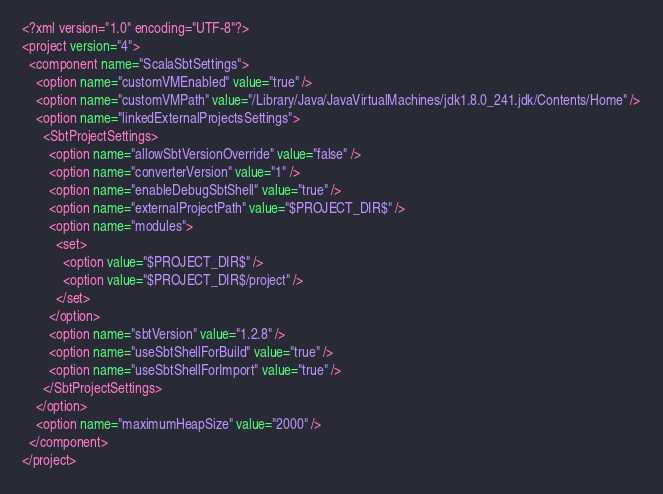<code> <loc_0><loc_0><loc_500><loc_500><_XML_><?xml version="1.0" encoding="UTF-8"?>
<project version="4">
  <component name="ScalaSbtSettings">
    <option name="customVMEnabled" value="true" />
    <option name="customVMPath" value="/Library/Java/JavaVirtualMachines/jdk1.8.0_241.jdk/Contents/Home" />
    <option name="linkedExternalProjectsSettings">
      <SbtProjectSettings>
        <option name="allowSbtVersionOverride" value="false" />
        <option name="converterVersion" value="1" />
        <option name="enableDebugSbtShell" value="true" />
        <option name="externalProjectPath" value="$PROJECT_DIR$" />
        <option name="modules">
          <set>
            <option value="$PROJECT_DIR$" />
            <option value="$PROJECT_DIR$/project" />
          </set>
        </option>
        <option name="sbtVersion" value="1.2.8" />
        <option name="useSbtShellForBuild" value="true" />
        <option name="useSbtShellForImport" value="true" />
      </SbtProjectSettings>
    </option>
    <option name="maximumHeapSize" value="2000" />
  </component>
</project></code> 